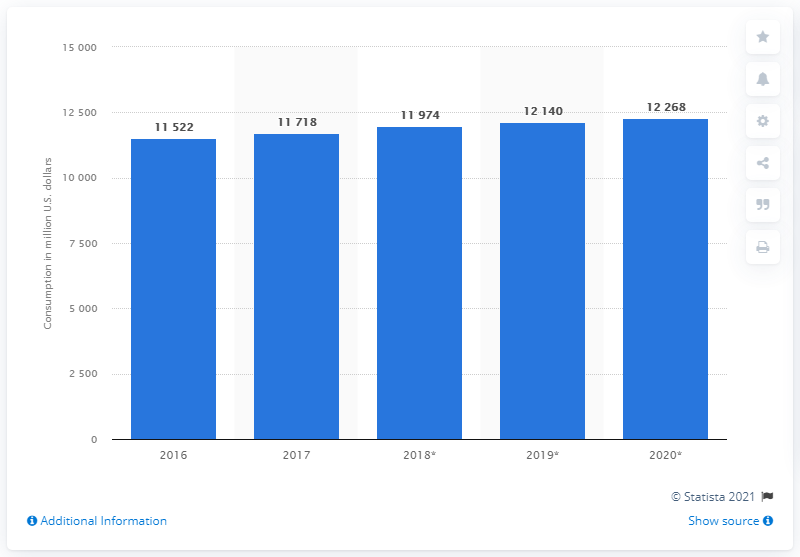List a handful of essential elements in this visual. The estimated amount of medical device consumption in Mexico by 2020 is projected to be 12,268 units. 